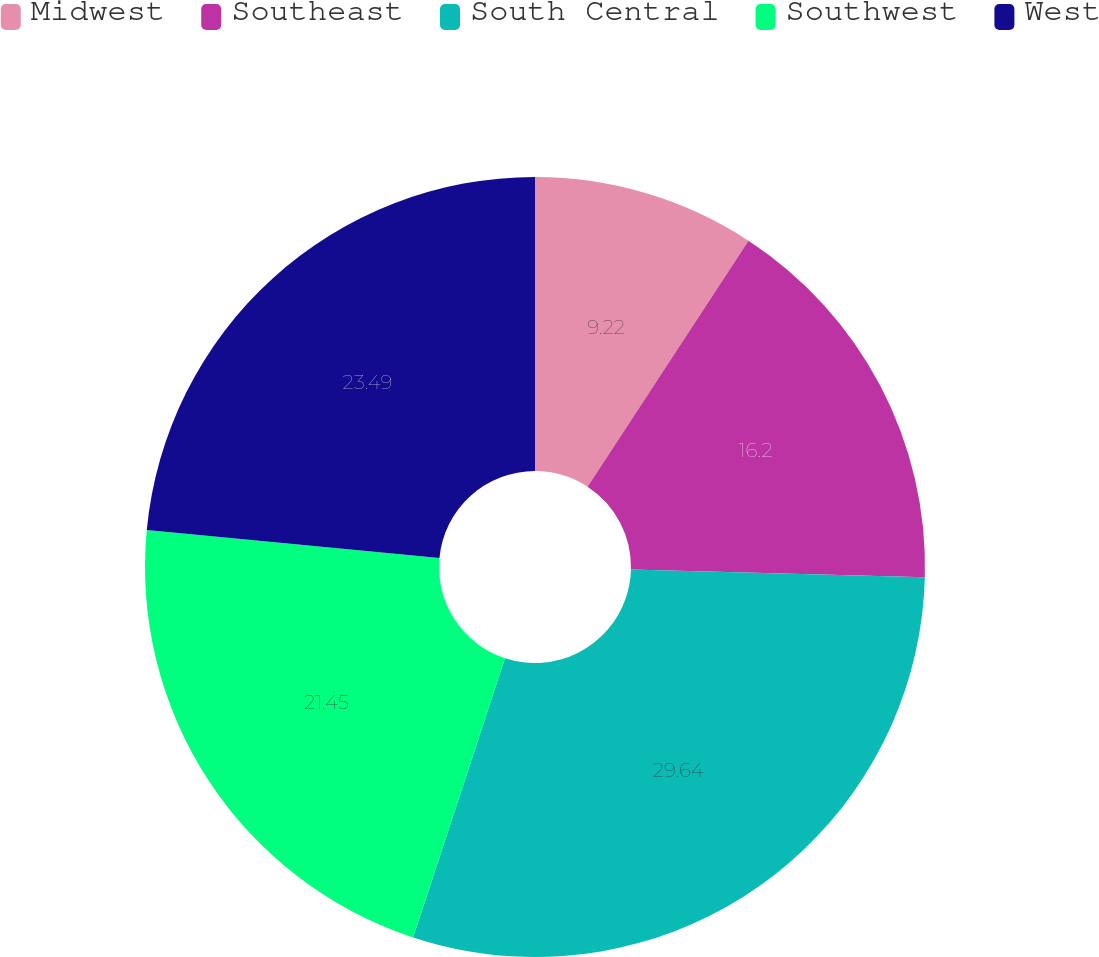Convert chart. <chart><loc_0><loc_0><loc_500><loc_500><pie_chart><fcel>Midwest<fcel>Southeast<fcel>South Central<fcel>Southwest<fcel>West<nl><fcel>9.22%<fcel>16.2%<fcel>29.64%<fcel>21.45%<fcel>23.49%<nl></chart> 